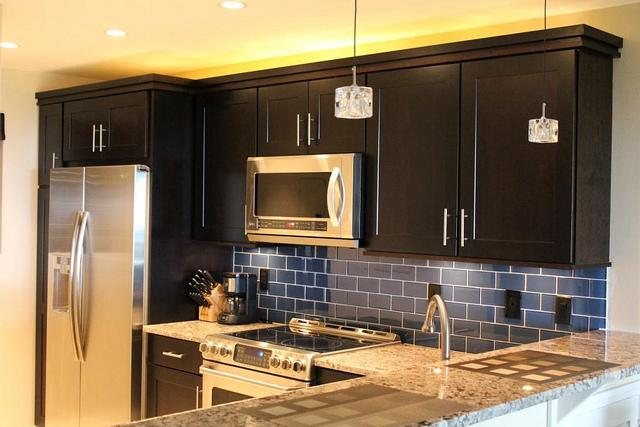What does the item with silver doors regulate? Please explain your reasoning. temperature. It's a refrigerator to keep food cold. 